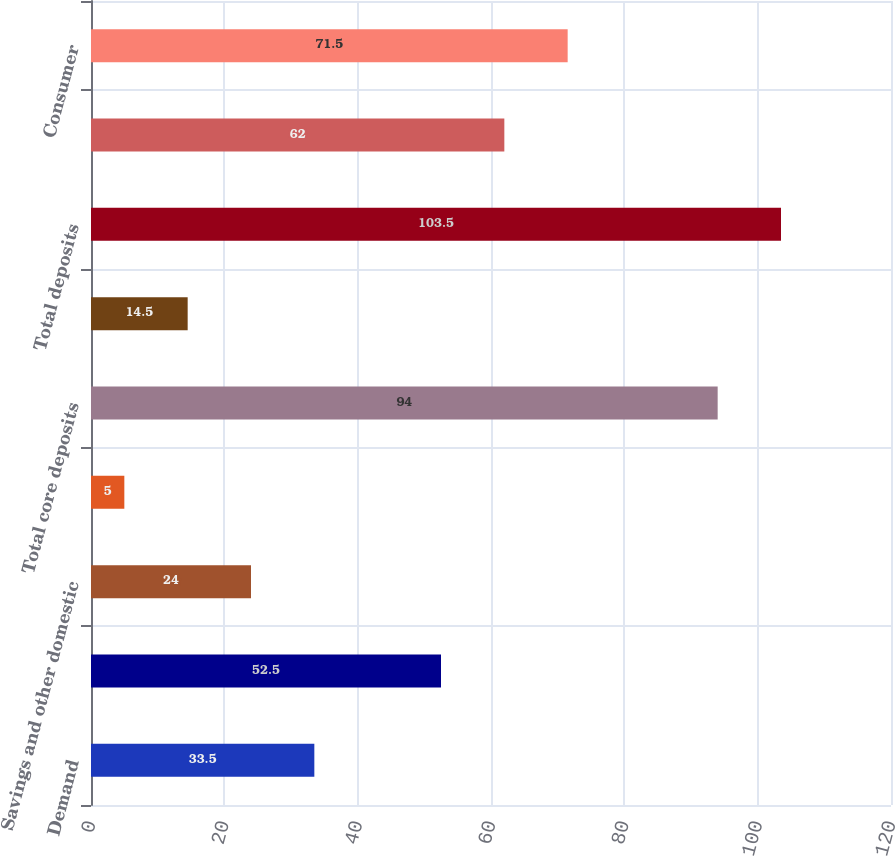Convert chart. <chart><loc_0><loc_0><loc_500><loc_500><bar_chart><fcel>Demand<fcel>Money market deposits<fcel>Savings and other domestic<fcel>Core certificates of deposit<fcel>Total core deposits<fcel>Brokered deposits and<fcel>Total deposits<fcel>Commercial<fcel>Consumer<nl><fcel>33.5<fcel>52.5<fcel>24<fcel>5<fcel>94<fcel>14.5<fcel>103.5<fcel>62<fcel>71.5<nl></chart> 